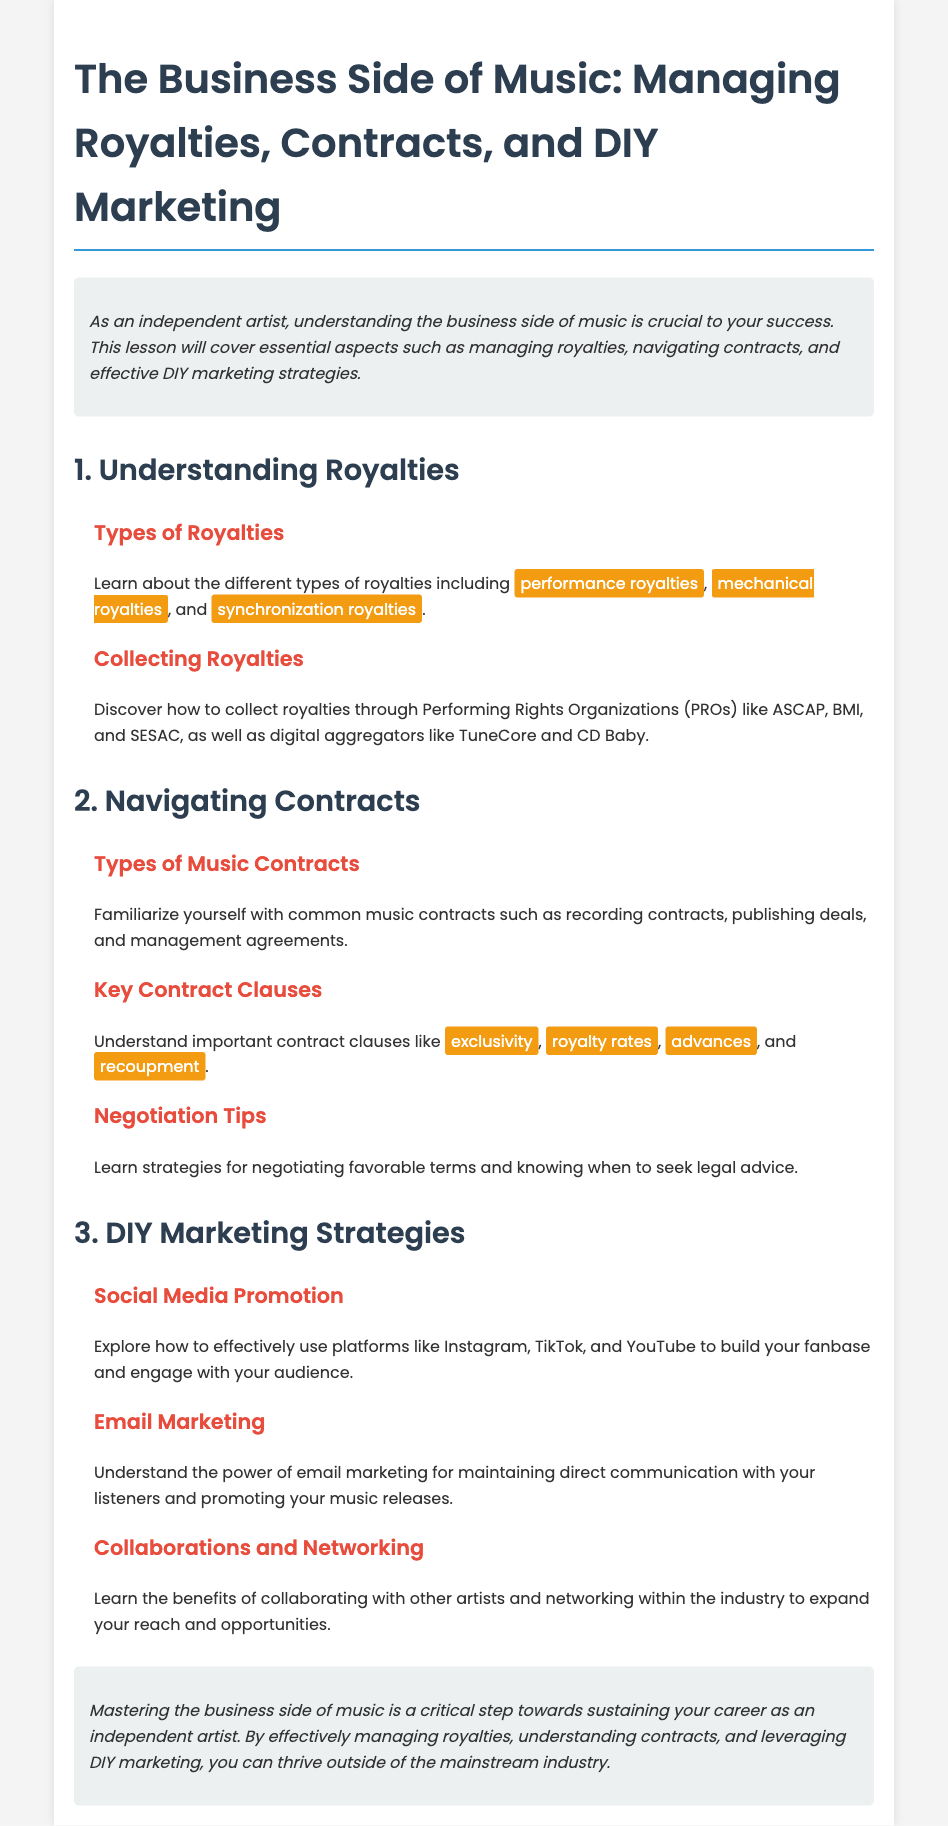what are the types of royalties mentioned? The document specifies three types of royalties: performance royalties, mechanical royalties, and synchronization royalties.
Answer: performance royalties, mechanical royalties, synchronization royalties what organizations help collect royalties? The document mentions Performing Rights Organizations (PROs) including ASCAP, BMI, and SESAC, and digital aggregators like TuneCore and CD Baby as entities that can help collect royalties.
Answer: ASCAP, BMI, SESAC, TuneCore, CD Baby what types of music contracts are highlighted? The document lists common music contracts, which include recording contracts, publishing deals, and management agreements.
Answer: recording contracts, publishing deals, management agreements name one key contract clause discussed. The document specifies key contract clauses such as exclusivity, royalty rates, advances, and recoupment.
Answer: exclusivity what is a DIY marketing strategy mentioned in the lesson plan? The document outlines several strategies, including social media promotion and email marketing, designed for independent artists to effectively communicate and engage with their audience.
Answer: social media promotion what is the main goal of mastering the business side of music? According to the conclusion, the main goal of mastering the business side of music is to sustain a career as an independent artist.
Answer: sustain your career who can seek legal advice according to the lesson plan? The document suggests that artists can seek legal advice when negotiating contracts, indicating the importance of understanding the terms fully before agreement.
Answer: artists which platforms are suggested for social media promotion? The lesson plan recommends using platforms like Instagram, TikTok, and YouTube for promoting music and building a fanbase.
Answer: Instagram, TikTok, YouTube 